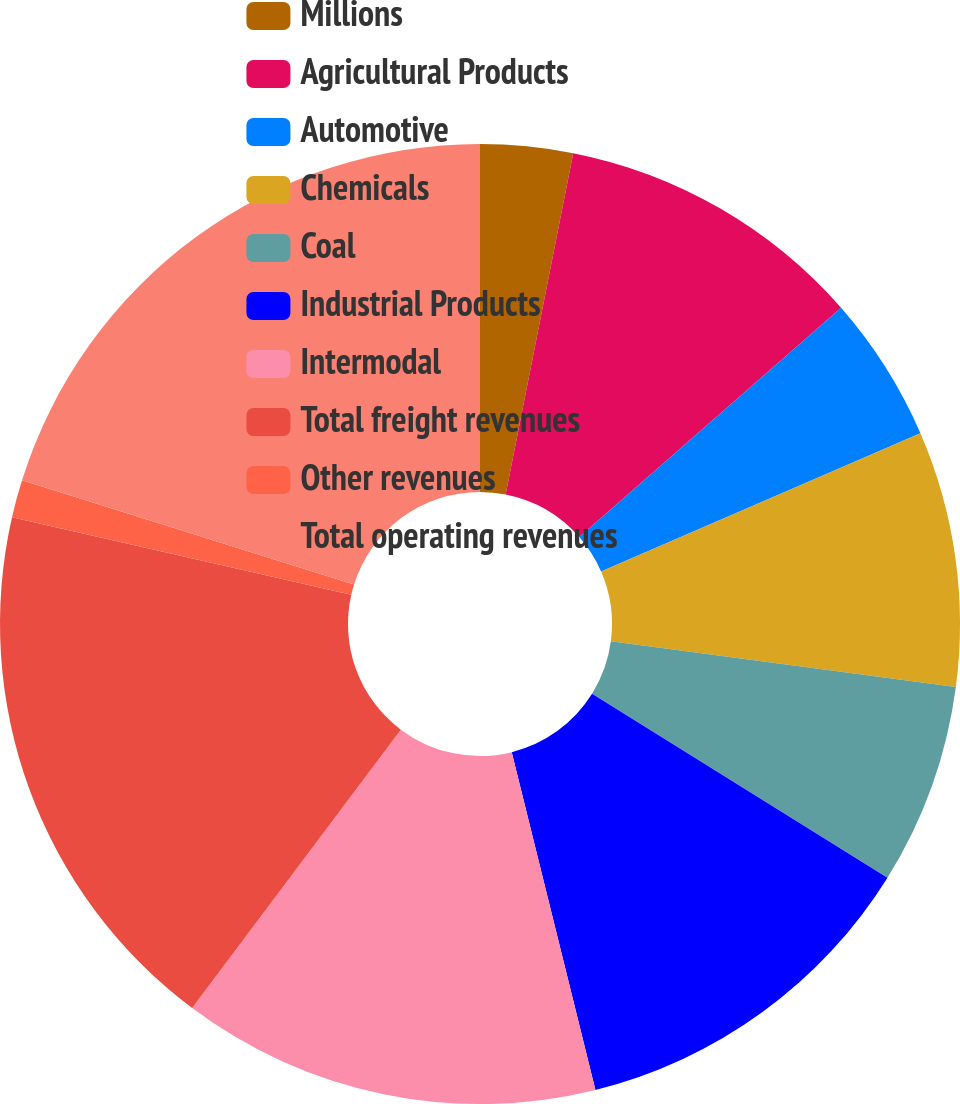<chart> <loc_0><loc_0><loc_500><loc_500><pie_chart><fcel>Millions<fcel>Agricultural Products<fcel>Automotive<fcel>Chemicals<fcel>Coal<fcel>Industrial Products<fcel>Intermodal<fcel>Total freight revenues<fcel>Other revenues<fcel>Total operating revenues<nl><fcel>3.11%<fcel>10.44%<fcel>4.94%<fcel>8.6%<fcel>6.77%<fcel>12.27%<fcel>14.1%<fcel>18.33%<fcel>1.27%<fcel>20.16%<nl></chart> 